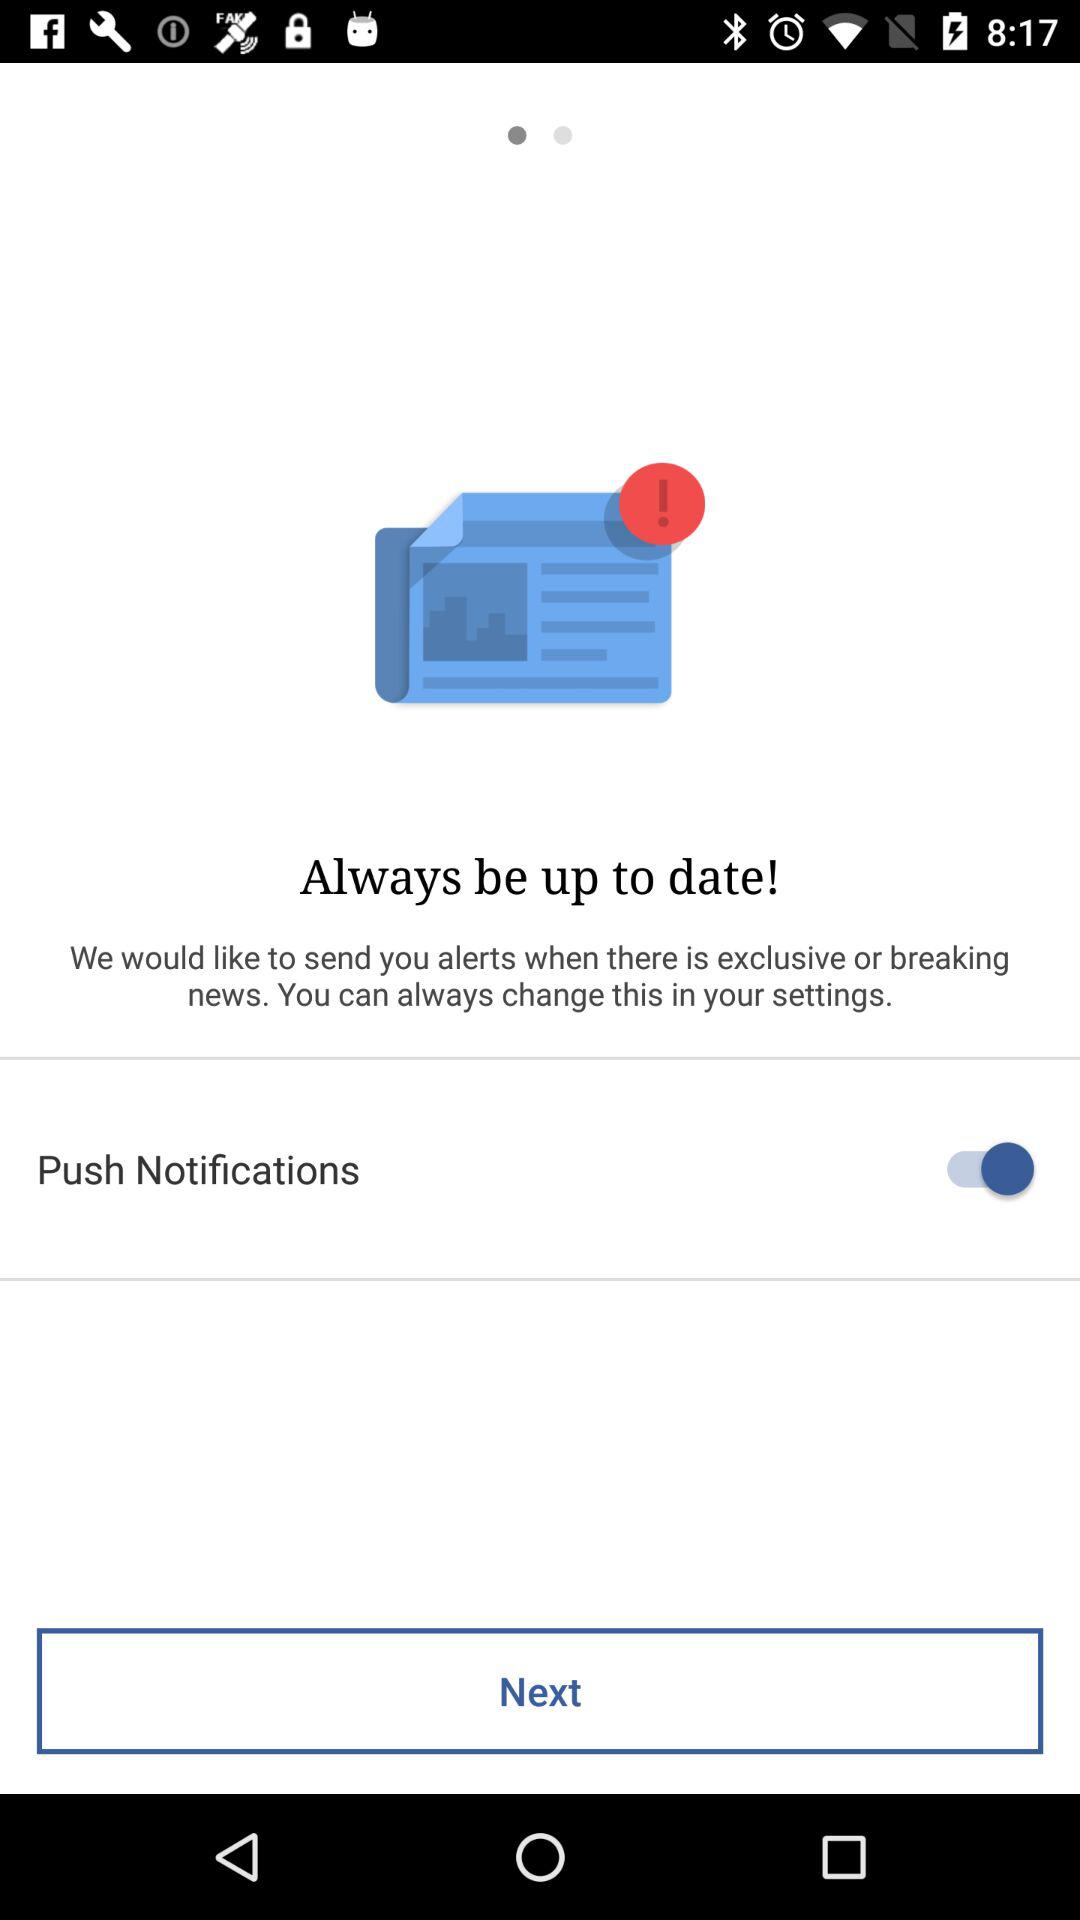What is the status of "Push Notification"? The status is "on". 